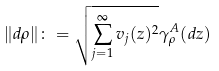<formula> <loc_0><loc_0><loc_500><loc_500>\| d \rho \| \colon = \sqrt { \sum _ { j = 1 } ^ { \infty } v _ { j } ( z ) ^ { 2 } } \gamma _ { \rho } ^ { A } ( d z )</formula> 